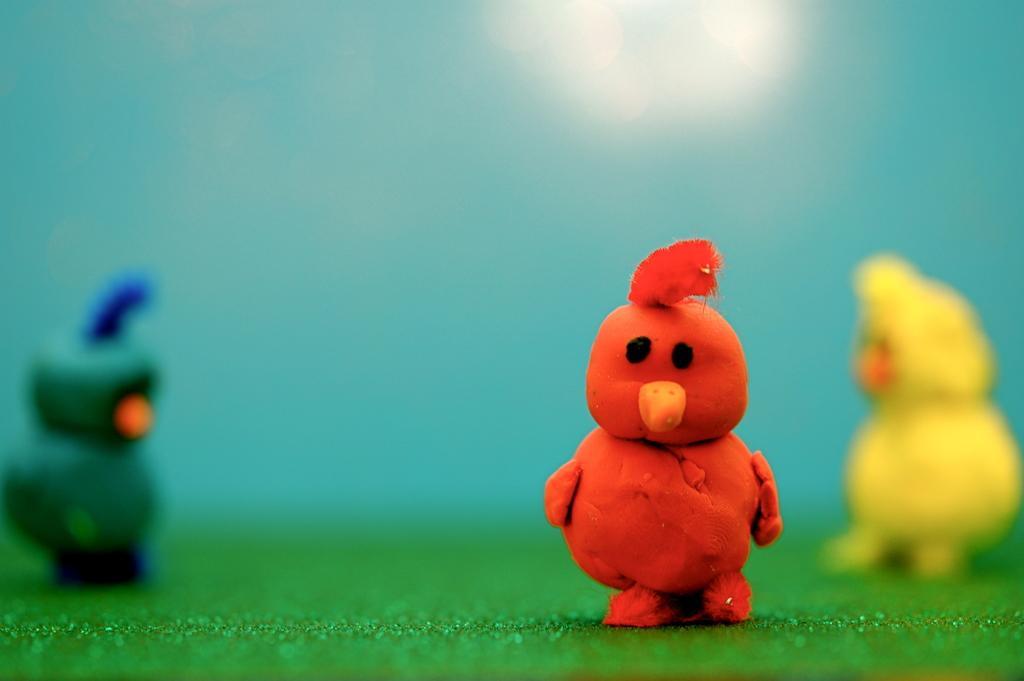Can you describe this image briefly? In the foreground, I can see a red color toy. In the background I can see two more toys which are in yellow and green color. These three toys are placed on a green color sheet. The background is blurred. 